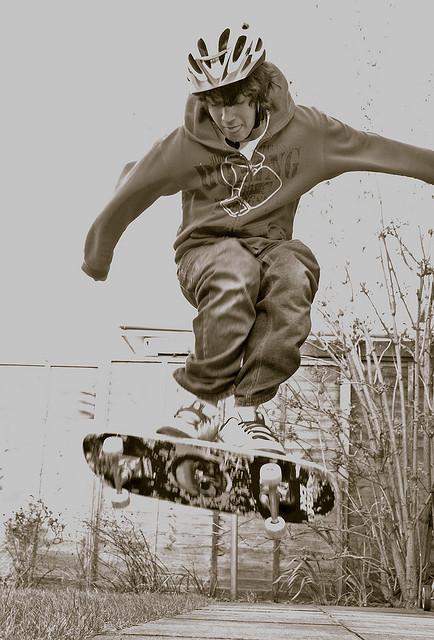Are the trees bare?
Short answer required. Yes. Is the photo colorful?
Be succinct. No. Is the skateboard in the air?
Concise answer only. Yes. 